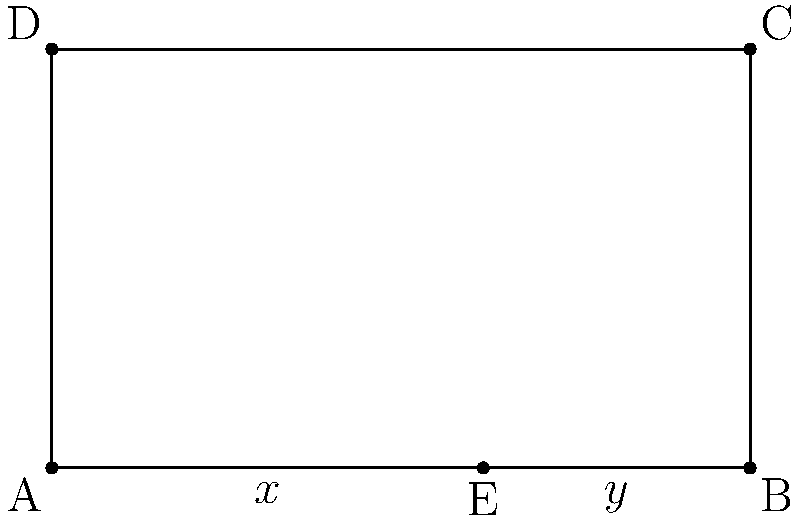In your latest street art mural, you've incorporated the golden ratio to create a visually appealing composition. The mural is represented by the rectangle ABCD, where point E divides the base AB according to the golden ratio. If the width of the mural is 5 units, what is the approximate length of AE (represented by $x$) to the nearest hundredth? To solve this problem, we'll use the properties of the golden ratio:

1) The golden ratio is approximately 1.618033988749895, often denoted by φ (phi).

2) In a golden ratio division, the ratio of the whole to the larger part is equal to the ratio of the larger part to the smaller part.

3) Let's denote AE as $x$ and EB as $y$. We know that AB = 5 units.

4) According to the golden ratio property:
   
   $$\frac{x+y}{x} = \frac{x}{y} = φ$$

5) We also know that $x + y = 5$ (the total width of the mural).

6) Substituting this into the golden ratio equation:
   
   $$\frac{5}{x} = φ$$

7) Solving for $x$:
   
   $$x = \frac{5}{φ}$$

8) Using the approximate value of φ:
   
   $$x = \frac{5}{1.618033988749895} ≈ 3.09016994$$

9) Rounding to the nearest hundredth:
   
   $$x ≈ 3.09$$

Therefore, the length of AE (represented by $x$) is approximately 3.09 units.
Answer: 3.09 units 